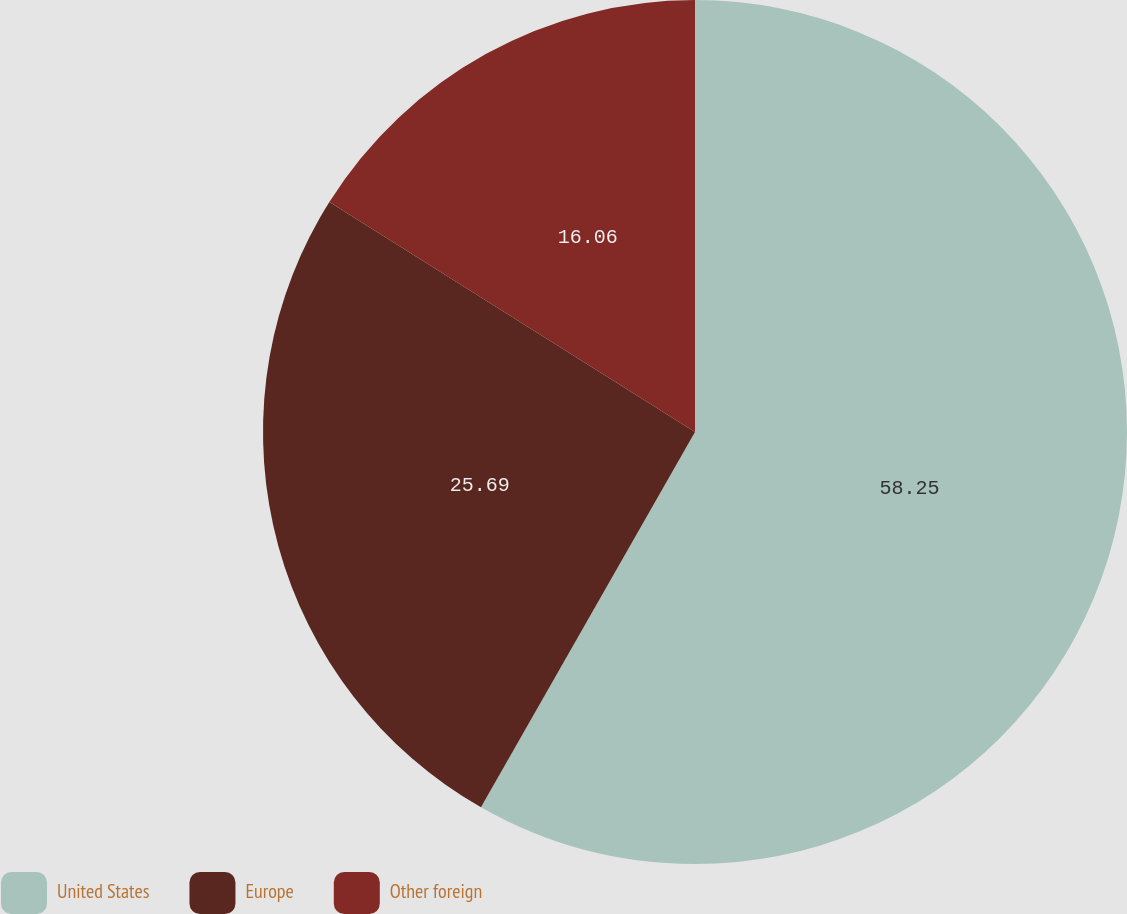<chart> <loc_0><loc_0><loc_500><loc_500><pie_chart><fcel>United States<fcel>Europe<fcel>Other foreign<nl><fcel>58.25%<fcel>25.69%<fcel>16.06%<nl></chart> 